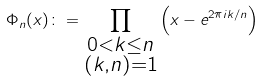<formula> <loc_0><loc_0><loc_500><loc_500>\Phi _ { n } ( x ) \colon = \prod _ { \substack { 0 < k \leq n \\ ( k , n ) = 1 } } \left ( x - e ^ { 2 \pi i k / n } \right )</formula> 